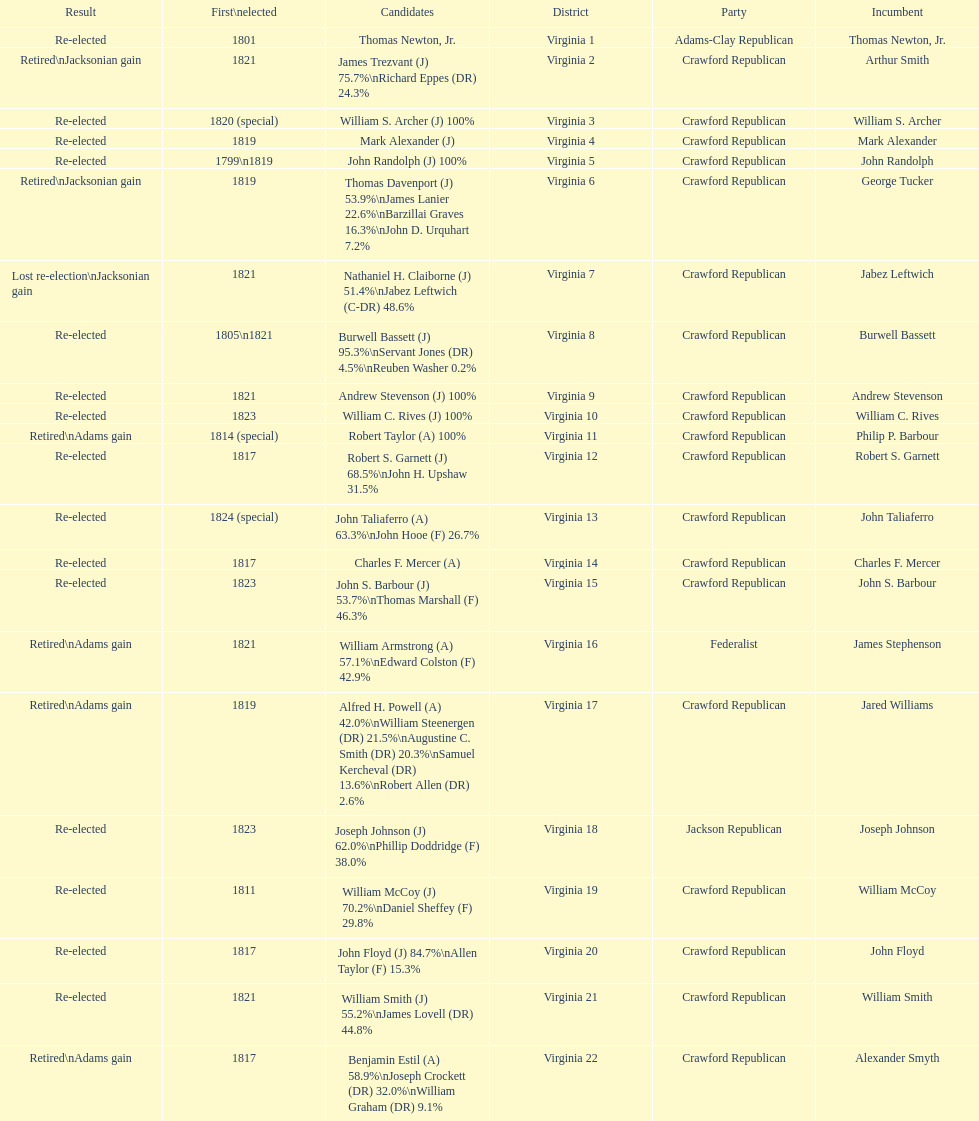How many applicants were there for the virginia 17th district? 5. 